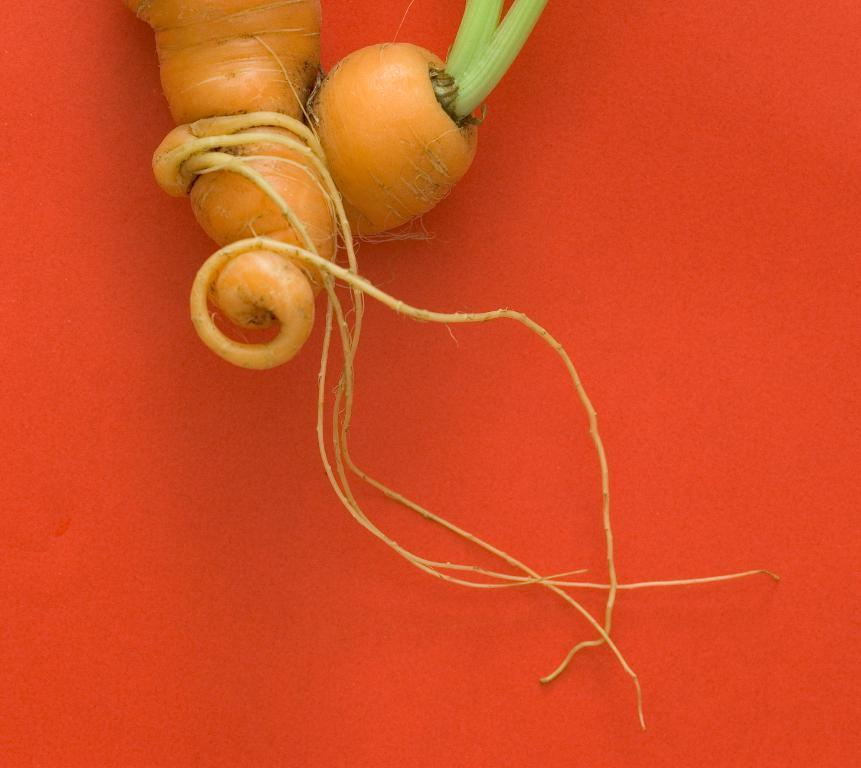What is the main subject of the image? The main subject of the image is a carrot. Where is the carrot located in the image? The carrot is placed on a table in the image. What type of insurance does the son have for the snakes in the image? There is no son, snakes, or insurance mentioned in the image. The image only features a carrot placed on a table. 